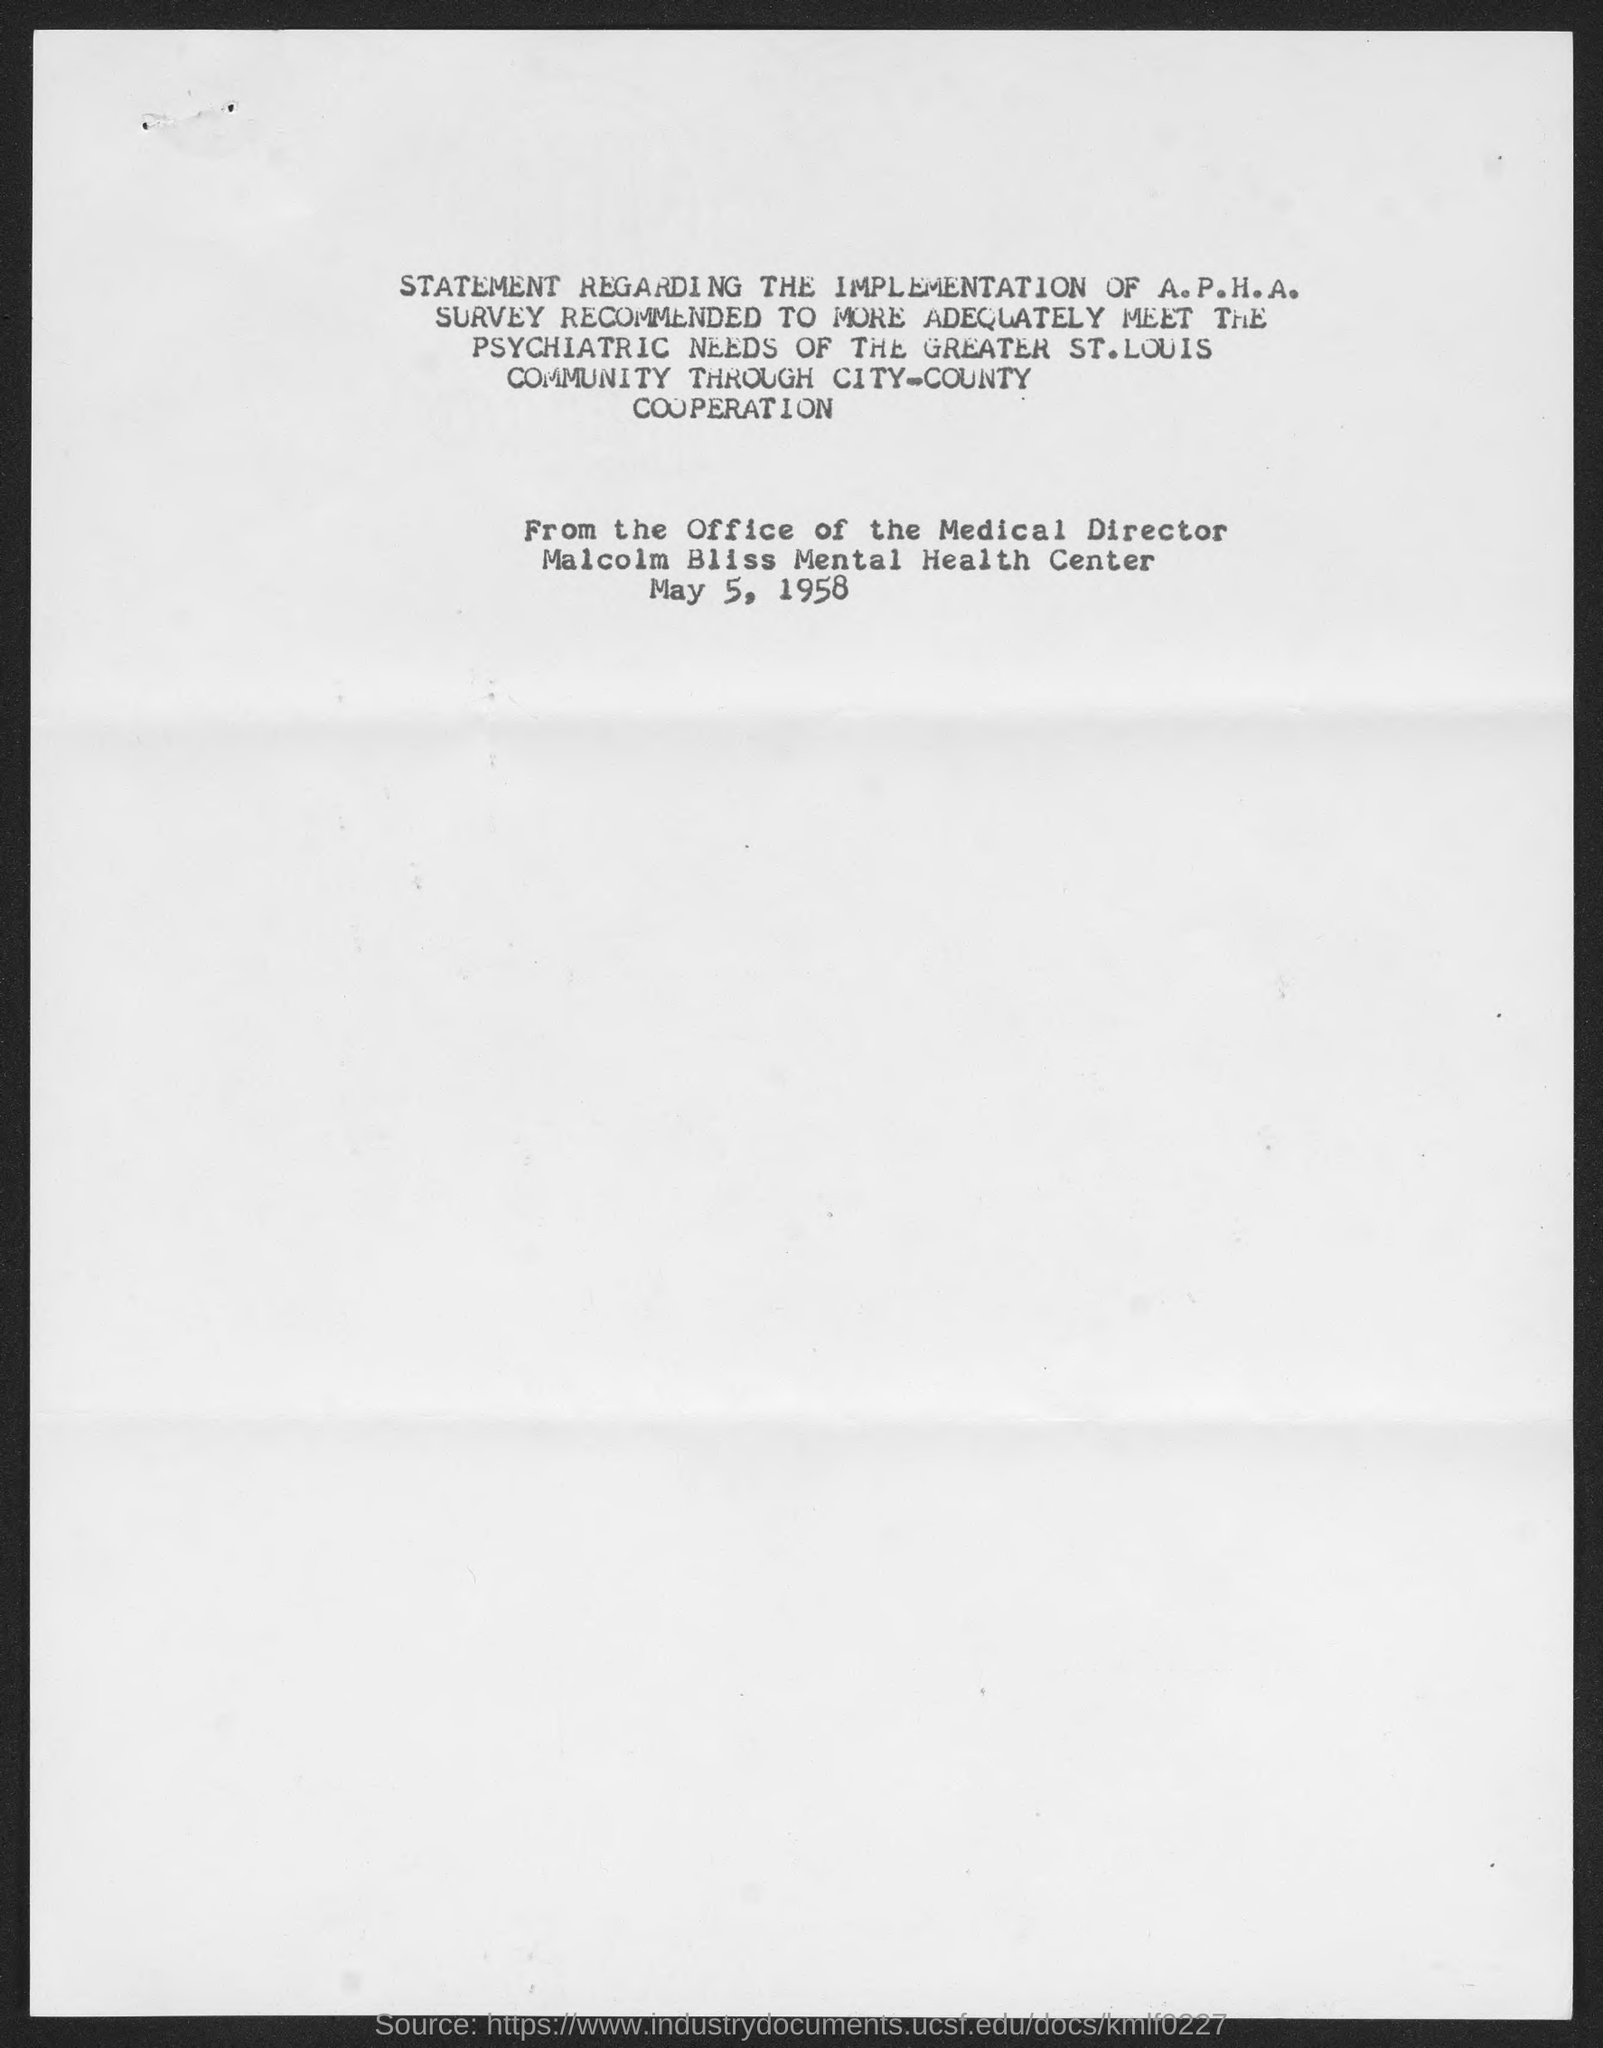Indicate a few pertinent items in this graphic. I have determined that the name of the mental health center is Malcolm Bliss mental health center. The date mentioned in the document is May 5, 1958. 